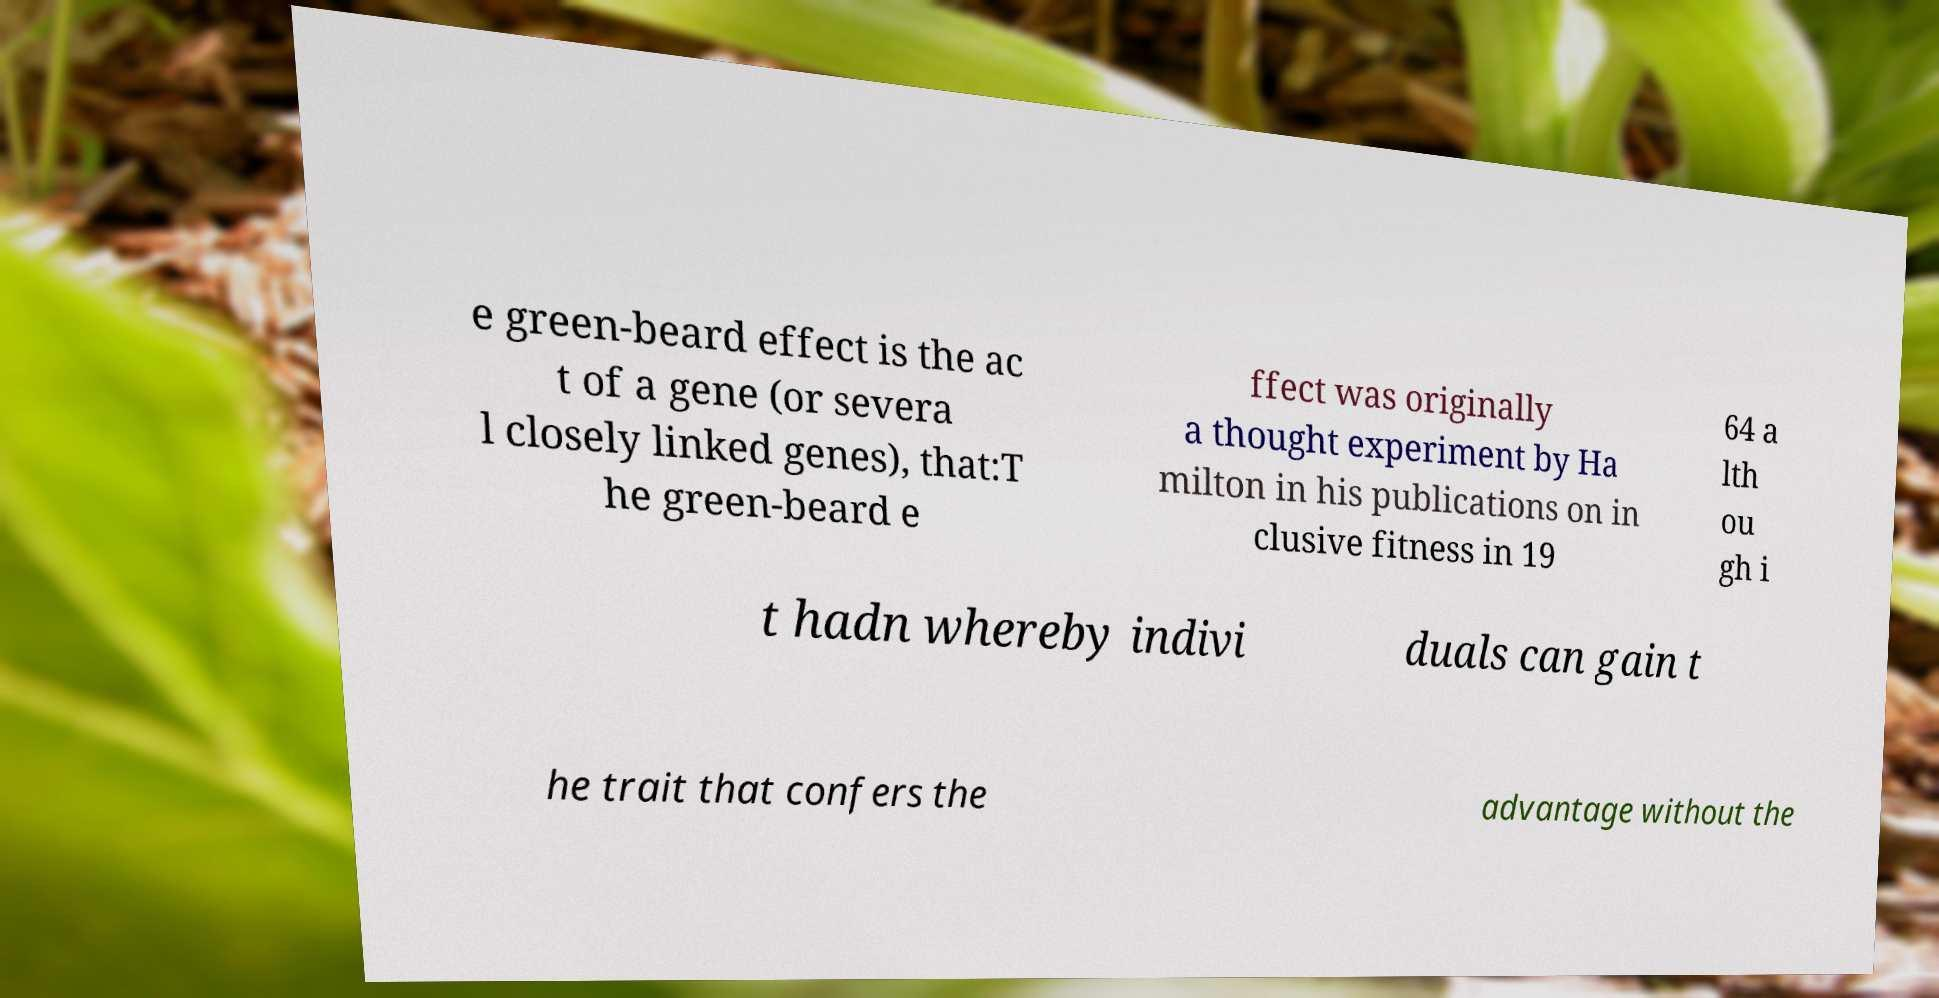Could you assist in decoding the text presented in this image and type it out clearly? e green-beard effect is the ac t of a gene (or severa l closely linked genes), that:T he green-beard e ffect was originally a thought experiment by Ha milton in his publications on in clusive fitness in 19 64 a lth ou gh i t hadn whereby indivi duals can gain t he trait that confers the advantage without the 